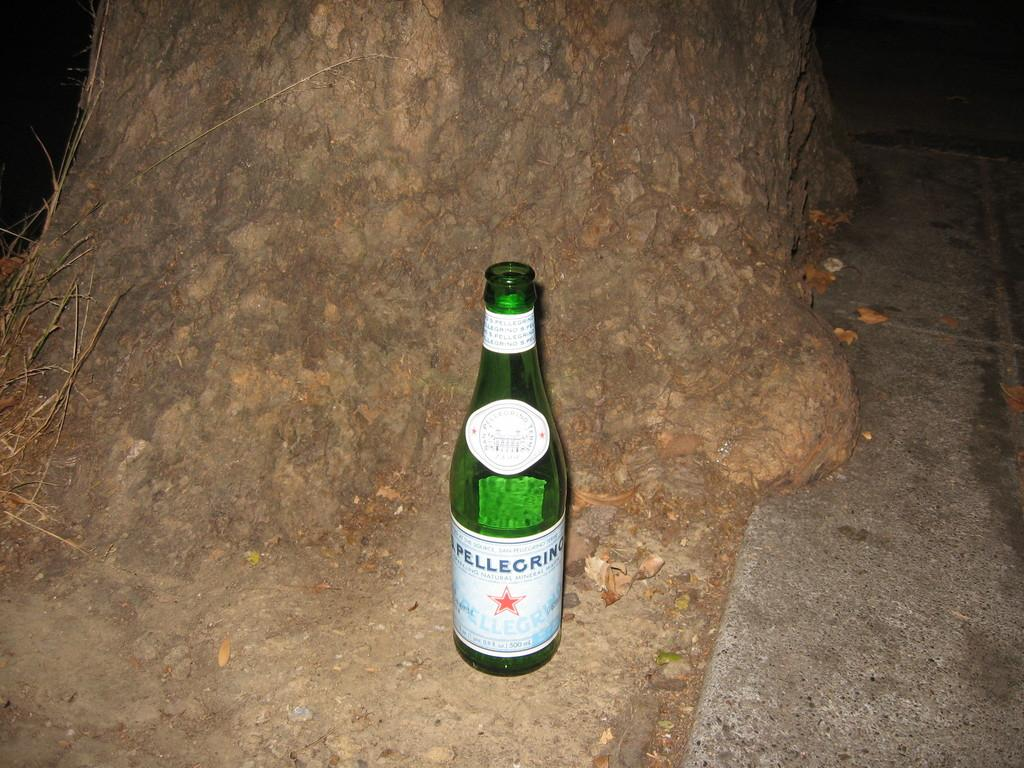<image>
Describe the image concisely. A lone bottle of San Pellegrino water sits at the bottom of a tree stump. 